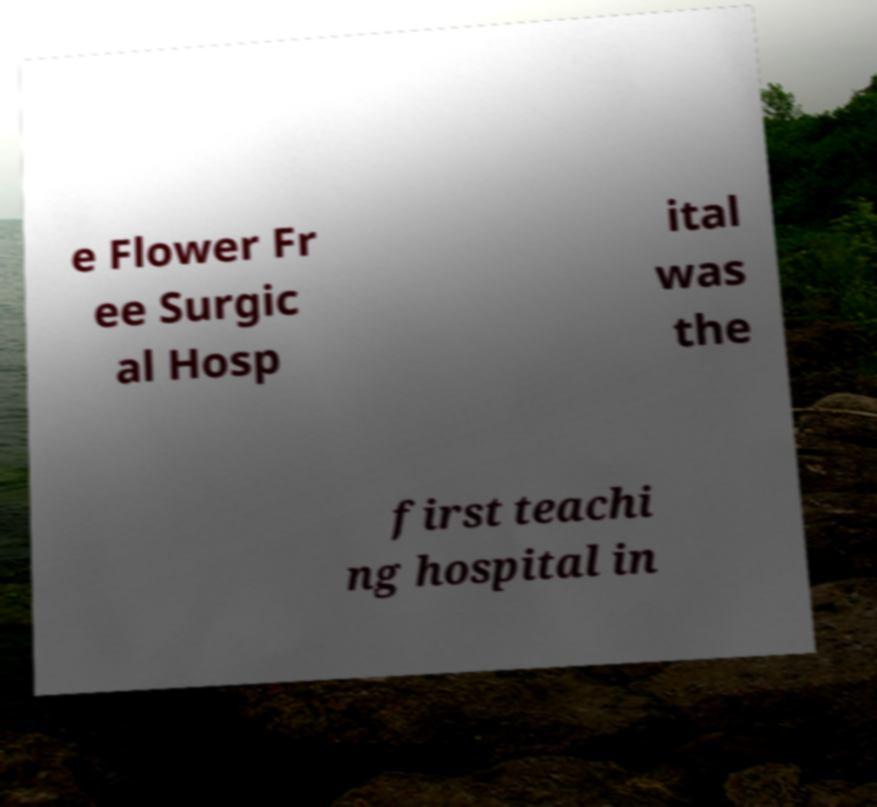Please read and relay the text visible in this image. What does it say? e Flower Fr ee Surgic al Hosp ital was the first teachi ng hospital in 